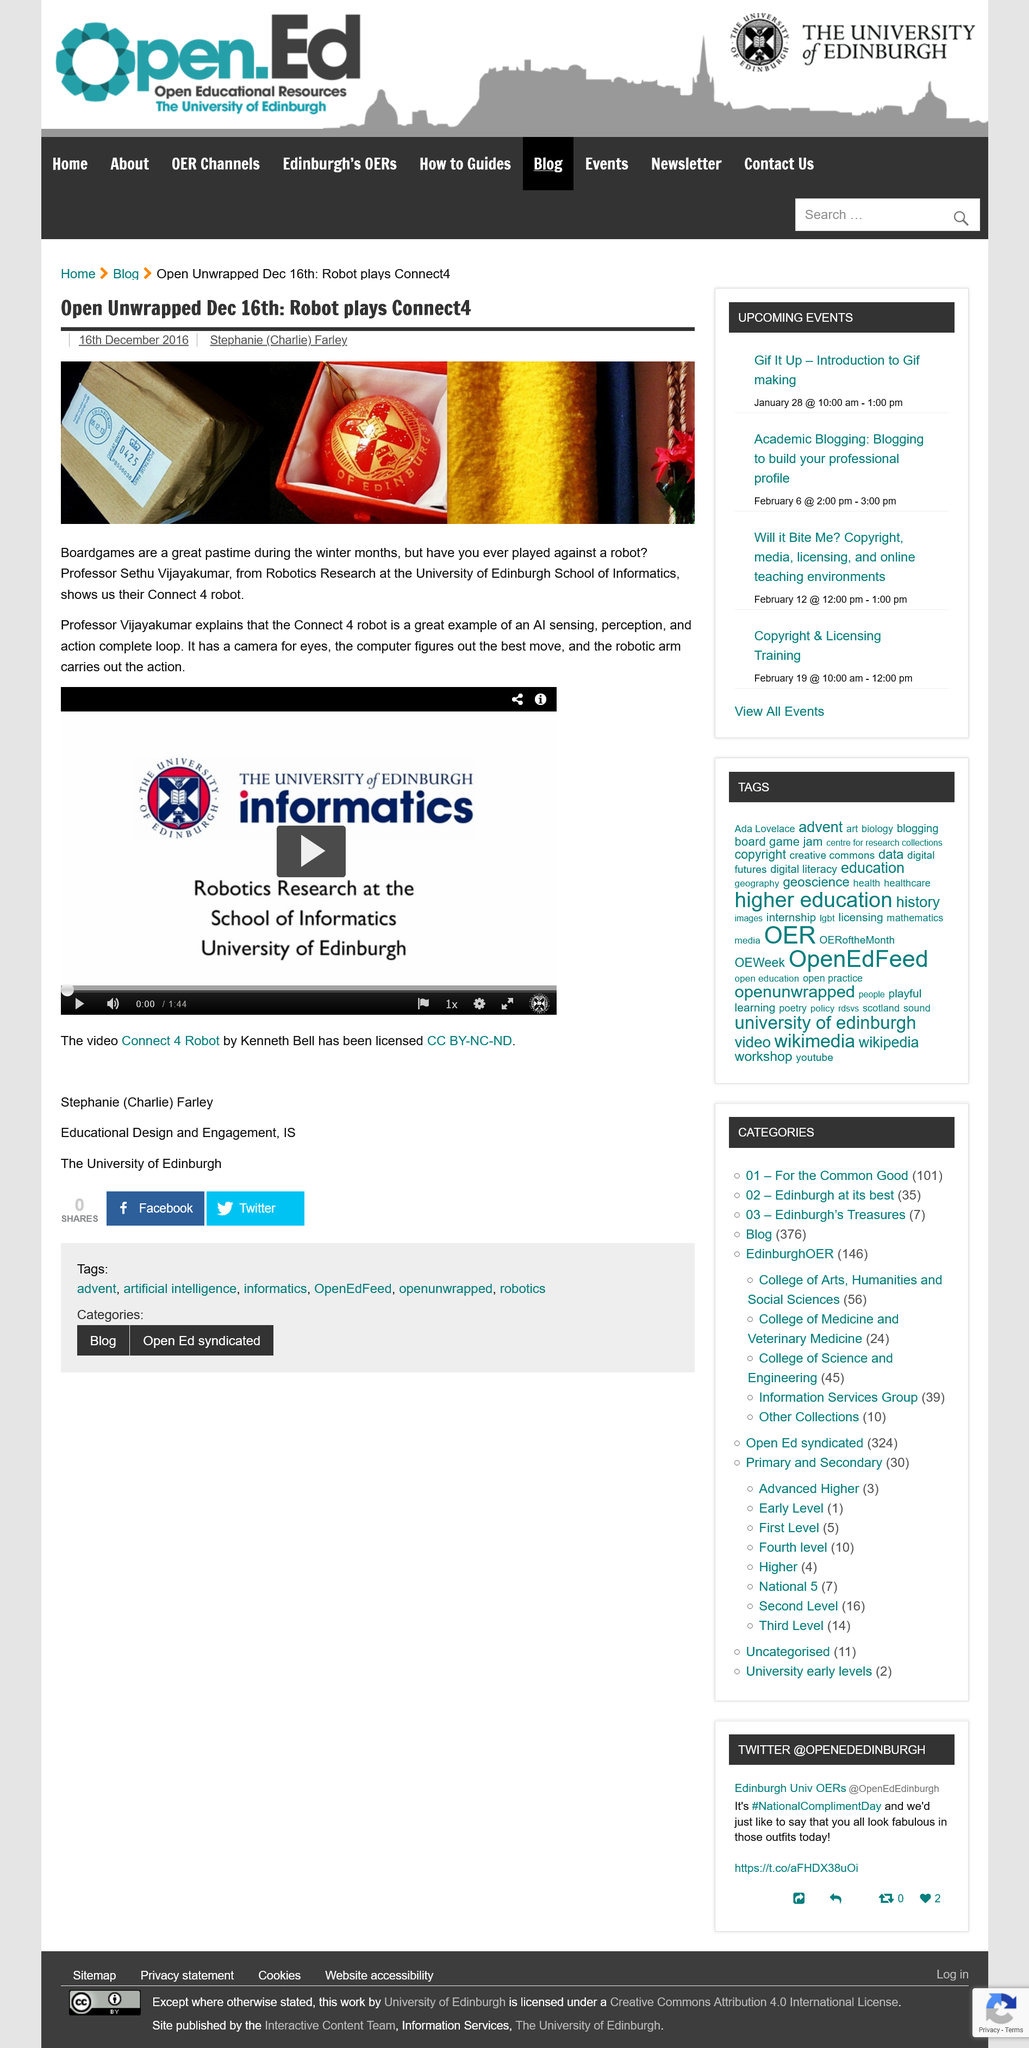Draw attention to some important aspects in this diagram. The Connect 4 robot is equipped with a camera as its primary means of visual perception. Sethu Vijayakumar is a professor at the University of Edinburgh, which is where he works. The image of the University of Edinburgh crest is related to the topic of a robot that plays Connect 4, as the robot was created by the University of Edinburgh School of Informatics. 